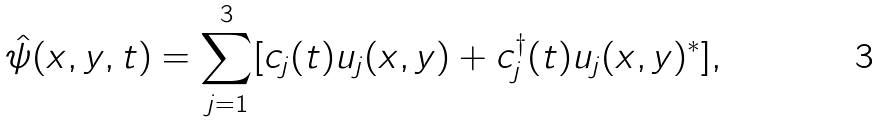Convert formula to latex. <formula><loc_0><loc_0><loc_500><loc_500>\hat { \psi } ( x , y , t ) = \sum _ { j = 1 } ^ { 3 } [ c _ { j } ( t ) u _ { j } ( x , y ) + c _ { j } ^ { \dagger } ( t ) u _ { j } ( x , y ) ^ { * } ] ,</formula> 